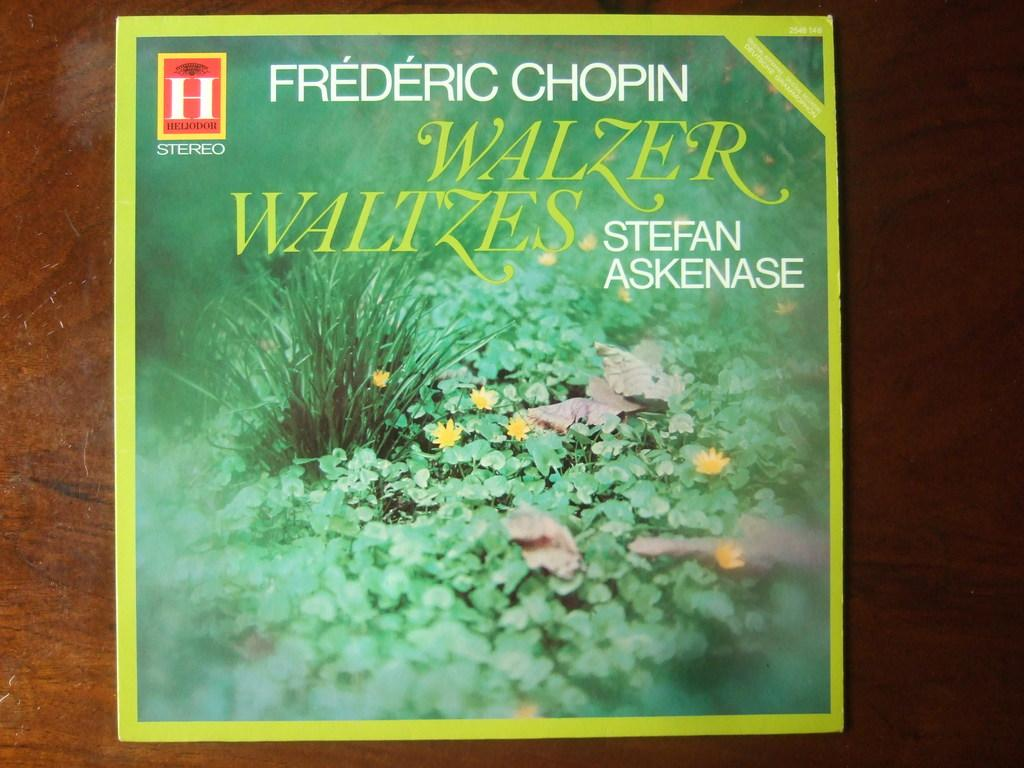<image>
Relay a brief, clear account of the picture shown. A Frederic Chopic Album Cover sits on a desk 